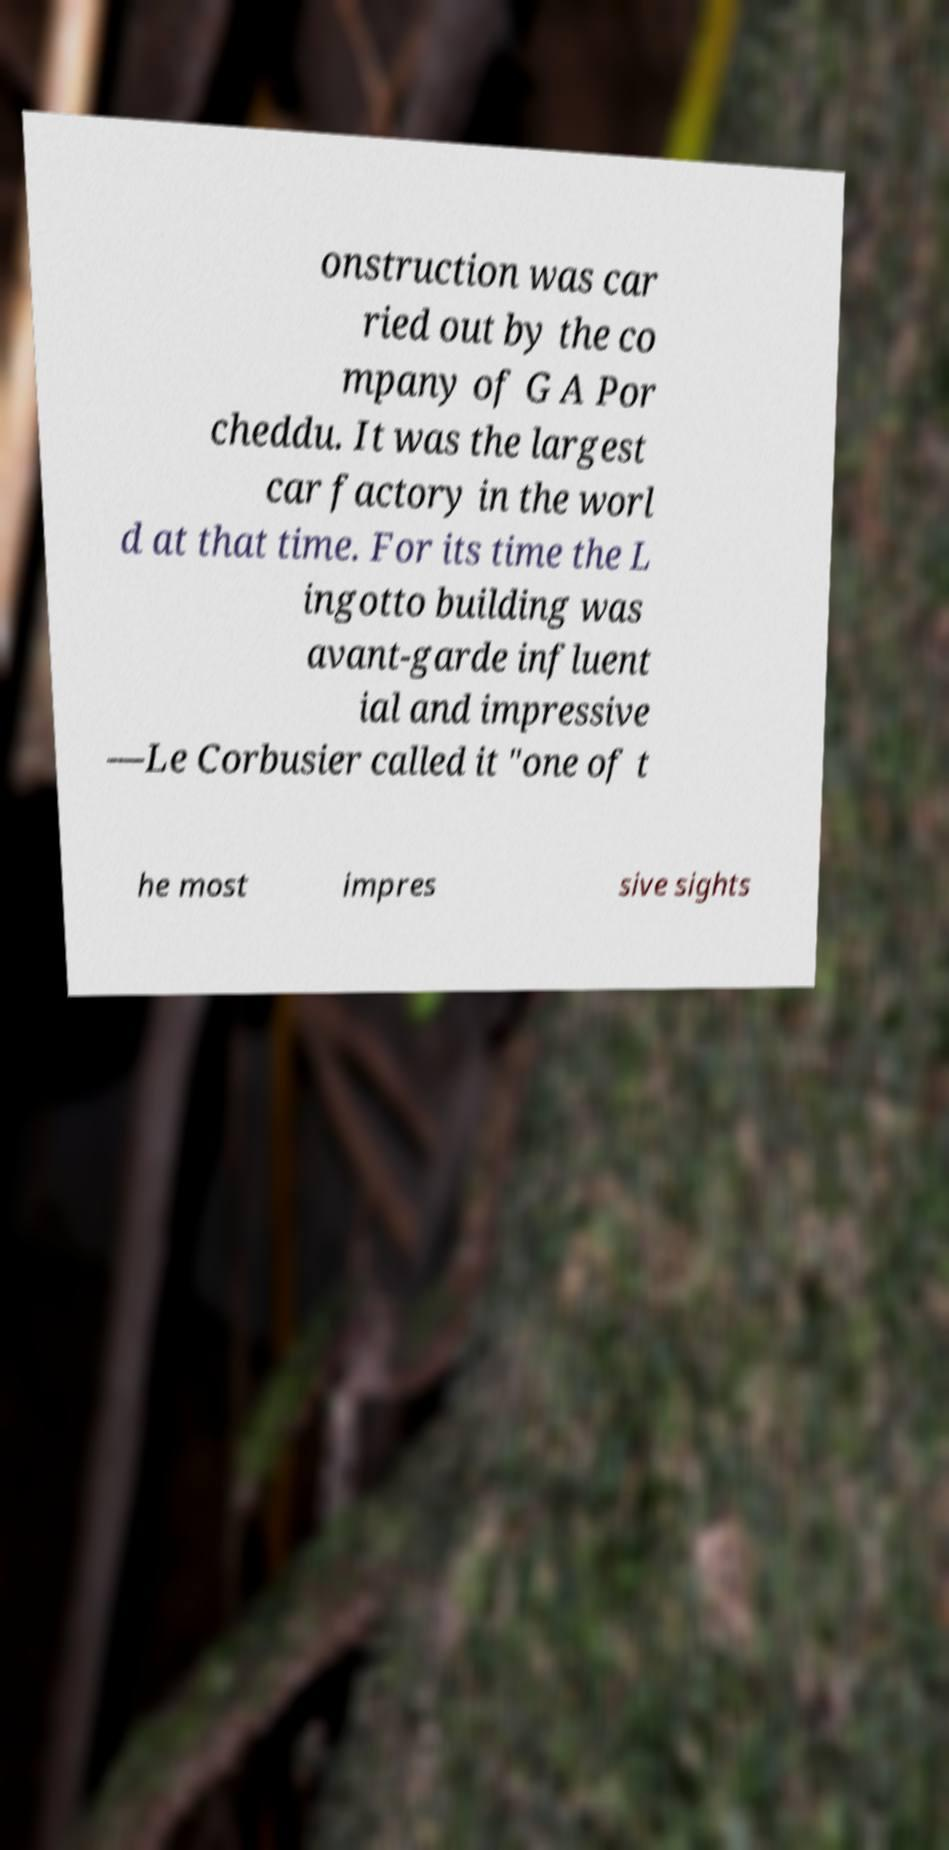There's text embedded in this image that I need extracted. Can you transcribe it verbatim? onstruction was car ried out by the co mpany of G A Por cheddu. It was the largest car factory in the worl d at that time. For its time the L ingotto building was avant-garde influent ial and impressive —Le Corbusier called it "one of t he most impres sive sights 